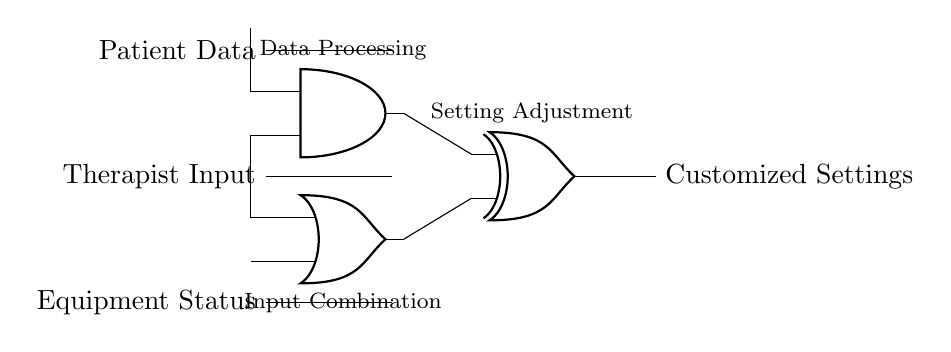What are the inputs to this circuit? The inputs to the circuit are "Patient Data" and "Therapist Input." These inputs are represented as signals arriving from the left side of the diagram towards the AND and OR gates.
Answer: Patient Data, Therapist Input What type of output does the circuit generate? The circuit generates "Customized Settings" as its output, which is derived from the operations performed by the logic gates on the inputs.
Answer: Customized Settings What function does the AND gate perform in this circuit? The AND gate processes the inputs by using a logical conjunction, meaning it only outputs a high signal when both of its inputs ("Patient Data" and "Equipment Status") are present.
Answer: Data Processing Which gates are used for combining inputs in the circuit? The circuit uses an AND gate and an OR gate for combining the inputs which utilize different logic operations to derive intermediate results before the final output.
Answer: AND gate, OR gate What is the role of the XOR gate in this circuit? The XOR gate serves to adjust the final settings based on the outputs of the AND and OR gates, providing a setting adjustment based on whether the inputs are different or not, hence controlling the output customization.
Answer: Setting Adjustment How many logic gates are present in the circuit? There are three logic gates present in the circuit: one AND gate, one OR gate, and one XOR gate. This is clear from their individual symbols on the diagram.
Answer: Three What operation does the OR gate perform in this circuit? The OR gate performs a logical disjunction, meaning it outputs a high signal if at least one of its inputs ("Therapist Input" and "Equipment Status") is high, allowing for flexibility in signal processing.
Answer: Input Combination 